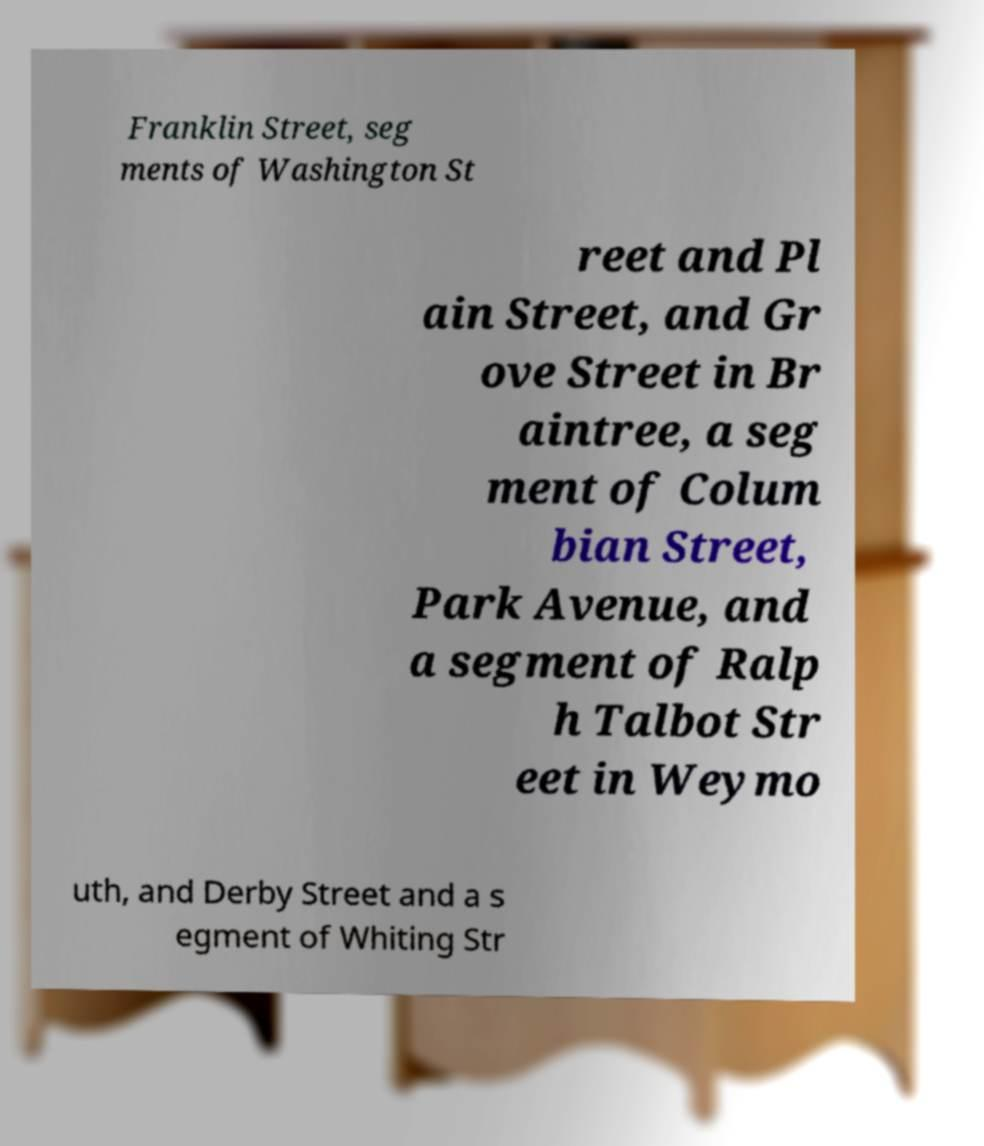Could you assist in decoding the text presented in this image and type it out clearly? Franklin Street, seg ments of Washington St reet and Pl ain Street, and Gr ove Street in Br aintree, a seg ment of Colum bian Street, Park Avenue, and a segment of Ralp h Talbot Str eet in Weymo uth, and Derby Street and a s egment of Whiting Str 